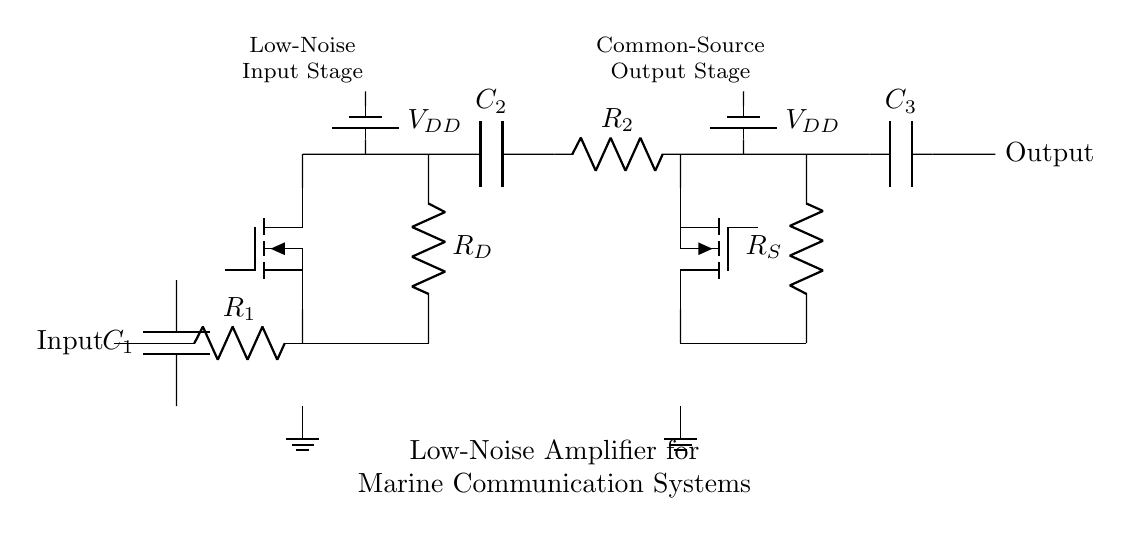What is the function of capacitor C1? Capacitor C1 is a coupling capacitor that blocks any DC component of the input signal and allows the AC component to pass through.
Answer: Coupling capacitor What is the type of transistors used in this amplifier? The amplifying stages use Tnigfete transistors, which are typically used for amplifying low-noise signals.
Answer: Tnigfete How many stages of amplification are there in this circuit? There are two stages of amplification: the low-noise input stage and the common-source output stage.
Answer: Two What is the value of resistor R1? The value of resistor R1 is not provided in the diagram; however, it is used to set the gain of the first stage.
Answer: Not specified What is the relationship between capacitors C2 and C3? C2 is used for coupling between the two amplifier stages, while C3 is the output coupling capacitor that transfers the signal to the output stage.
Answer: Coupling function What does R_D represent? R_D is the drain resistor for the first transistor stage, and it plays a crucial role in determining the gain and stability of the amplification.
Answer: Drain resistor What type of signal does the output provide? The output provides an amplified version of the input signal, designed for marine communication applications.
Answer: Amplified signal 